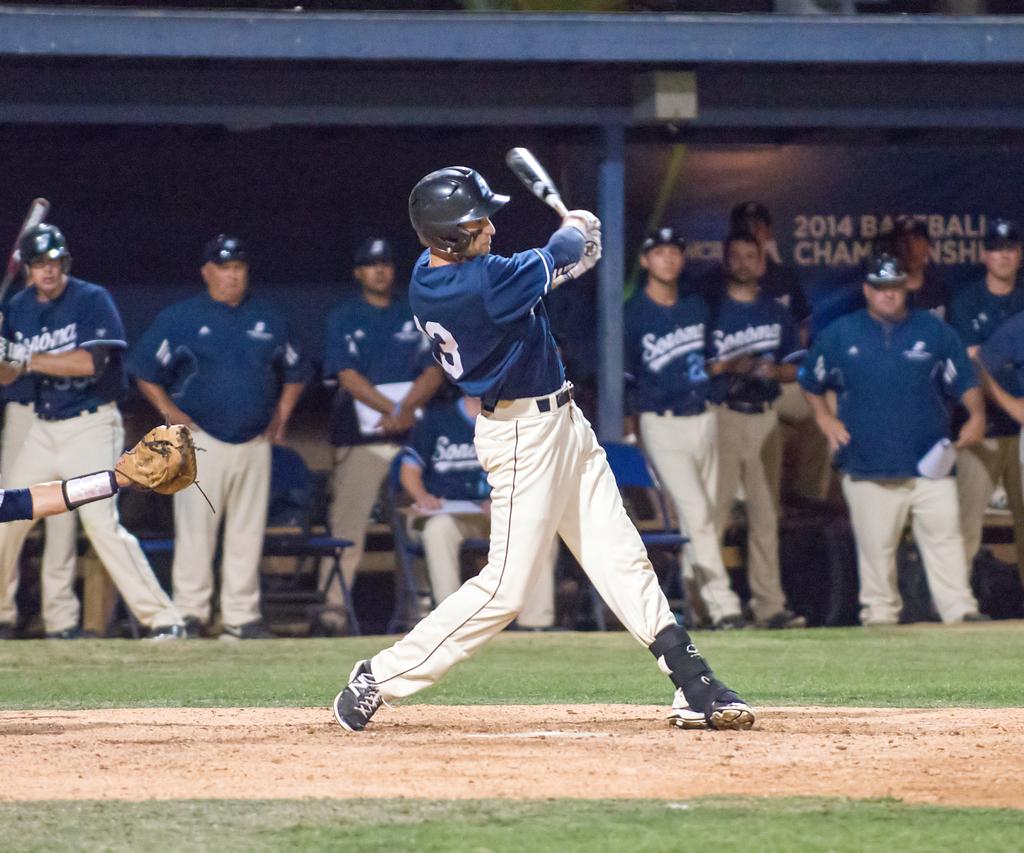What team name is on the jerseys?
Provide a succinct answer. Sonoma. 